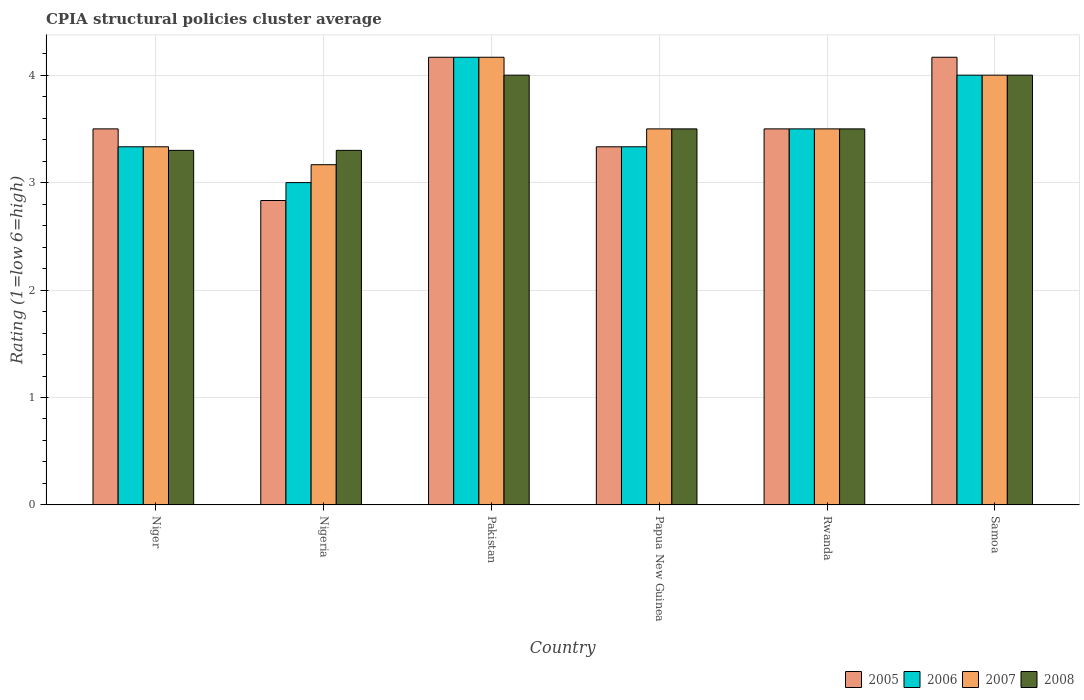How many groups of bars are there?
Offer a terse response. 6. Are the number of bars per tick equal to the number of legend labels?
Ensure brevity in your answer.  Yes. How many bars are there on the 2nd tick from the left?
Your response must be concise. 4. How many bars are there on the 6th tick from the right?
Make the answer very short. 4. What is the label of the 4th group of bars from the left?
Your response must be concise. Papua New Guinea. What is the CPIA rating in 2005 in Niger?
Provide a short and direct response. 3.5. Across all countries, what is the maximum CPIA rating in 2008?
Give a very brief answer. 4. Across all countries, what is the minimum CPIA rating in 2005?
Provide a short and direct response. 2.83. In which country was the CPIA rating in 2007 minimum?
Provide a succinct answer. Nigeria. What is the total CPIA rating in 2008 in the graph?
Offer a terse response. 21.6. What is the difference between the CPIA rating in 2005 in Papua New Guinea and the CPIA rating in 2007 in Nigeria?
Ensure brevity in your answer.  0.17. What is the average CPIA rating in 2008 per country?
Your answer should be compact. 3.6. What is the difference between the CPIA rating of/in 2008 and CPIA rating of/in 2006 in Papua New Guinea?
Your response must be concise. 0.17. What is the ratio of the CPIA rating in 2007 in Nigeria to that in Papua New Guinea?
Provide a succinct answer. 0.9. Is the CPIA rating in 2006 in Nigeria less than that in Pakistan?
Keep it short and to the point. Yes. What is the difference between the highest and the second highest CPIA rating in 2008?
Offer a very short reply. -0.5. What is the difference between the highest and the lowest CPIA rating in 2007?
Make the answer very short. 1. In how many countries, is the CPIA rating in 2006 greater than the average CPIA rating in 2006 taken over all countries?
Your response must be concise. 2. What does the 1st bar from the left in Samoa represents?
Your answer should be compact. 2005. Are all the bars in the graph horizontal?
Your answer should be compact. No. What is the difference between two consecutive major ticks on the Y-axis?
Your response must be concise. 1. Does the graph contain any zero values?
Make the answer very short. No. How many legend labels are there?
Make the answer very short. 4. How are the legend labels stacked?
Offer a very short reply. Horizontal. What is the title of the graph?
Give a very brief answer. CPIA structural policies cluster average. Does "1978" appear as one of the legend labels in the graph?
Your response must be concise. No. What is the label or title of the Y-axis?
Your answer should be very brief. Rating (1=low 6=high). What is the Rating (1=low 6=high) in 2005 in Niger?
Keep it short and to the point. 3.5. What is the Rating (1=low 6=high) in 2006 in Niger?
Keep it short and to the point. 3.33. What is the Rating (1=low 6=high) of 2007 in Niger?
Keep it short and to the point. 3.33. What is the Rating (1=low 6=high) in 2005 in Nigeria?
Your answer should be compact. 2.83. What is the Rating (1=low 6=high) of 2007 in Nigeria?
Make the answer very short. 3.17. What is the Rating (1=low 6=high) in 2005 in Pakistan?
Keep it short and to the point. 4.17. What is the Rating (1=low 6=high) in 2006 in Pakistan?
Keep it short and to the point. 4.17. What is the Rating (1=low 6=high) in 2007 in Pakistan?
Your answer should be very brief. 4.17. What is the Rating (1=low 6=high) of 2008 in Pakistan?
Ensure brevity in your answer.  4. What is the Rating (1=low 6=high) in 2005 in Papua New Guinea?
Ensure brevity in your answer.  3.33. What is the Rating (1=low 6=high) of 2006 in Papua New Guinea?
Offer a very short reply. 3.33. What is the Rating (1=low 6=high) of 2008 in Papua New Guinea?
Give a very brief answer. 3.5. What is the Rating (1=low 6=high) in 2005 in Rwanda?
Provide a short and direct response. 3.5. What is the Rating (1=low 6=high) in 2006 in Rwanda?
Provide a short and direct response. 3.5. What is the Rating (1=low 6=high) of 2008 in Rwanda?
Provide a short and direct response. 3.5. What is the Rating (1=low 6=high) in 2005 in Samoa?
Provide a short and direct response. 4.17. Across all countries, what is the maximum Rating (1=low 6=high) of 2005?
Your response must be concise. 4.17. Across all countries, what is the maximum Rating (1=low 6=high) in 2006?
Make the answer very short. 4.17. Across all countries, what is the maximum Rating (1=low 6=high) of 2007?
Offer a very short reply. 4.17. Across all countries, what is the maximum Rating (1=low 6=high) in 2008?
Offer a very short reply. 4. Across all countries, what is the minimum Rating (1=low 6=high) of 2005?
Your answer should be very brief. 2.83. Across all countries, what is the minimum Rating (1=low 6=high) in 2007?
Offer a terse response. 3.17. Across all countries, what is the minimum Rating (1=low 6=high) in 2008?
Provide a short and direct response. 3.3. What is the total Rating (1=low 6=high) of 2006 in the graph?
Your response must be concise. 21.33. What is the total Rating (1=low 6=high) in 2007 in the graph?
Make the answer very short. 21.67. What is the total Rating (1=low 6=high) of 2008 in the graph?
Keep it short and to the point. 21.6. What is the difference between the Rating (1=low 6=high) in 2006 in Niger and that in Nigeria?
Ensure brevity in your answer.  0.33. What is the difference between the Rating (1=low 6=high) in 2007 in Niger and that in Nigeria?
Make the answer very short. 0.17. What is the difference between the Rating (1=low 6=high) in 2005 in Niger and that in Pakistan?
Make the answer very short. -0.67. What is the difference between the Rating (1=low 6=high) in 2006 in Niger and that in Pakistan?
Provide a short and direct response. -0.83. What is the difference between the Rating (1=low 6=high) in 2008 in Niger and that in Pakistan?
Give a very brief answer. -0.7. What is the difference between the Rating (1=low 6=high) in 2005 in Niger and that in Papua New Guinea?
Make the answer very short. 0.17. What is the difference between the Rating (1=low 6=high) in 2006 in Niger and that in Papua New Guinea?
Provide a short and direct response. 0. What is the difference between the Rating (1=low 6=high) in 2007 in Niger and that in Papua New Guinea?
Your answer should be very brief. -0.17. What is the difference between the Rating (1=low 6=high) in 2005 in Niger and that in Rwanda?
Keep it short and to the point. 0. What is the difference between the Rating (1=low 6=high) in 2006 in Niger and that in Rwanda?
Provide a short and direct response. -0.17. What is the difference between the Rating (1=low 6=high) in 2008 in Niger and that in Rwanda?
Offer a terse response. -0.2. What is the difference between the Rating (1=low 6=high) of 2005 in Niger and that in Samoa?
Provide a short and direct response. -0.67. What is the difference between the Rating (1=low 6=high) of 2005 in Nigeria and that in Pakistan?
Provide a short and direct response. -1.33. What is the difference between the Rating (1=low 6=high) in 2006 in Nigeria and that in Pakistan?
Give a very brief answer. -1.17. What is the difference between the Rating (1=low 6=high) in 2008 in Nigeria and that in Pakistan?
Your answer should be compact. -0.7. What is the difference between the Rating (1=low 6=high) in 2005 in Nigeria and that in Papua New Guinea?
Offer a very short reply. -0.5. What is the difference between the Rating (1=low 6=high) of 2005 in Nigeria and that in Rwanda?
Provide a short and direct response. -0.67. What is the difference between the Rating (1=low 6=high) in 2006 in Nigeria and that in Rwanda?
Your response must be concise. -0.5. What is the difference between the Rating (1=low 6=high) of 2008 in Nigeria and that in Rwanda?
Keep it short and to the point. -0.2. What is the difference between the Rating (1=low 6=high) of 2005 in Nigeria and that in Samoa?
Make the answer very short. -1.33. What is the difference between the Rating (1=low 6=high) of 2006 in Nigeria and that in Samoa?
Your answer should be very brief. -1. What is the difference between the Rating (1=low 6=high) of 2008 in Nigeria and that in Samoa?
Your answer should be compact. -0.7. What is the difference between the Rating (1=low 6=high) in 2006 in Pakistan and that in Papua New Guinea?
Your response must be concise. 0.83. What is the difference between the Rating (1=low 6=high) in 2007 in Pakistan and that in Papua New Guinea?
Ensure brevity in your answer.  0.67. What is the difference between the Rating (1=low 6=high) of 2005 in Pakistan and that in Rwanda?
Offer a very short reply. 0.67. What is the difference between the Rating (1=low 6=high) of 2006 in Pakistan and that in Rwanda?
Your response must be concise. 0.67. What is the difference between the Rating (1=low 6=high) of 2007 in Pakistan and that in Rwanda?
Give a very brief answer. 0.67. What is the difference between the Rating (1=low 6=high) of 2008 in Pakistan and that in Rwanda?
Make the answer very short. 0.5. What is the difference between the Rating (1=low 6=high) of 2005 in Pakistan and that in Samoa?
Offer a terse response. 0. What is the difference between the Rating (1=low 6=high) of 2007 in Pakistan and that in Samoa?
Offer a very short reply. 0.17. What is the difference between the Rating (1=low 6=high) in 2005 in Papua New Guinea and that in Rwanda?
Offer a terse response. -0.17. What is the difference between the Rating (1=low 6=high) in 2008 in Papua New Guinea and that in Samoa?
Offer a very short reply. -0.5. What is the difference between the Rating (1=low 6=high) of 2006 in Rwanda and that in Samoa?
Keep it short and to the point. -0.5. What is the difference between the Rating (1=low 6=high) in 2007 in Rwanda and that in Samoa?
Your answer should be very brief. -0.5. What is the difference between the Rating (1=low 6=high) in 2005 in Niger and the Rating (1=low 6=high) in 2008 in Nigeria?
Your response must be concise. 0.2. What is the difference between the Rating (1=low 6=high) of 2006 in Niger and the Rating (1=low 6=high) of 2007 in Nigeria?
Offer a very short reply. 0.17. What is the difference between the Rating (1=low 6=high) in 2007 in Niger and the Rating (1=low 6=high) in 2008 in Nigeria?
Your response must be concise. 0.03. What is the difference between the Rating (1=low 6=high) in 2005 in Niger and the Rating (1=low 6=high) in 2008 in Papua New Guinea?
Keep it short and to the point. 0. What is the difference between the Rating (1=low 6=high) in 2006 in Niger and the Rating (1=low 6=high) in 2007 in Papua New Guinea?
Offer a very short reply. -0.17. What is the difference between the Rating (1=low 6=high) in 2007 in Niger and the Rating (1=low 6=high) in 2008 in Papua New Guinea?
Provide a short and direct response. -0.17. What is the difference between the Rating (1=low 6=high) of 2006 in Niger and the Rating (1=low 6=high) of 2008 in Rwanda?
Your answer should be very brief. -0.17. What is the difference between the Rating (1=low 6=high) in 2007 in Niger and the Rating (1=low 6=high) in 2008 in Rwanda?
Ensure brevity in your answer.  -0.17. What is the difference between the Rating (1=low 6=high) in 2005 in Niger and the Rating (1=low 6=high) in 2006 in Samoa?
Your response must be concise. -0.5. What is the difference between the Rating (1=low 6=high) in 2007 in Niger and the Rating (1=low 6=high) in 2008 in Samoa?
Your answer should be very brief. -0.67. What is the difference between the Rating (1=low 6=high) in 2005 in Nigeria and the Rating (1=low 6=high) in 2006 in Pakistan?
Make the answer very short. -1.33. What is the difference between the Rating (1=low 6=high) in 2005 in Nigeria and the Rating (1=low 6=high) in 2007 in Pakistan?
Give a very brief answer. -1.33. What is the difference between the Rating (1=low 6=high) of 2005 in Nigeria and the Rating (1=low 6=high) of 2008 in Pakistan?
Keep it short and to the point. -1.17. What is the difference between the Rating (1=low 6=high) in 2006 in Nigeria and the Rating (1=low 6=high) in 2007 in Pakistan?
Your answer should be very brief. -1.17. What is the difference between the Rating (1=low 6=high) in 2006 in Nigeria and the Rating (1=low 6=high) in 2008 in Pakistan?
Provide a succinct answer. -1. What is the difference between the Rating (1=low 6=high) in 2005 in Nigeria and the Rating (1=low 6=high) in 2008 in Papua New Guinea?
Your answer should be compact. -0.67. What is the difference between the Rating (1=low 6=high) of 2006 in Nigeria and the Rating (1=low 6=high) of 2008 in Papua New Guinea?
Give a very brief answer. -0.5. What is the difference between the Rating (1=low 6=high) in 2005 in Nigeria and the Rating (1=low 6=high) in 2008 in Rwanda?
Keep it short and to the point. -0.67. What is the difference between the Rating (1=low 6=high) in 2006 in Nigeria and the Rating (1=low 6=high) in 2008 in Rwanda?
Provide a succinct answer. -0.5. What is the difference between the Rating (1=low 6=high) of 2005 in Nigeria and the Rating (1=low 6=high) of 2006 in Samoa?
Ensure brevity in your answer.  -1.17. What is the difference between the Rating (1=low 6=high) in 2005 in Nigeria and the Rating (1=low 6=high) in 2007 in Samoa?
Make the answer very short. -1.17. What is the difference between the Rating (1=low 6=high) of 2005 in Nigeria and the Rating (1=low 6=high) of 2008 in Samoa?
Your answer should be very brief. -1.17. What is the difference between the Rating (1=low 6=high) of 2006 in Nigeria and the Rating (1=low 6=high) of 2008 in Samoa?
Your answer should be very brief. -1. What is the difference between the Rating (1=low 6=high) of 2007 in Nigeria and the Rating (1=low 6=high) of 2008 in Samoa?
Give a very brief answer. -0.83. What is the difference between the Rating (1=low 6=high) of 2005 in Pakistan and the Rating (1=low 6=high) of 2006 in Papua New Guinea?
Offer a very short reply. 0.83. What is the difference between the Rating (1=low 6=high) of 2005 in Pakistan and the Rating (1=low 6=high) of 2007 in Papua New Guinea?
Make the answer very short. 0.67. What is the difference between the Rating (1=low 6=high) of 2006 in Pakistan and the Rating (1=low 6=high) of 2007 in Papua New Guinea?
Provide a short and direct response. 0.67. What is the difference between the Rating (1=low 6=high) in 2006 in Pakistan and the Rating (1=low 6=high) in 2008 in Papua New Guinea?
Offer a terse response. 0.67. What is the difference between the Rating (1=low 6=high) in 2007 in Pakistan and the Rating (1=low 6=high) in 2008 in Papua New Guinea?
Offer a terse response. 0.67. What is the difference between the Rating (1=low 6=high) of 2005 in Pakistan and the Rating (1=low 6=high) of 2006 in Rwanda?
Your answer should be compact. 0.67. What is the difference between the Rating (1=low 6=high) of 2005 in Pakistan and the Rating (1=low 6=high) of 2008 in Rwanda?
Give a very brief answer. 0.67. What is the difference between the Rating (1=low 6=high) in 2006 in Pakistan and the Rating (1=low 6=high) in 2007 in Rwanda?
Provide a succinct answer. 0.67. What is the difference between the Rating (1=low 6=high) of 2006 in Pakistan and the Rating (1=low 6=high) of 2008 in Rwanda?
Ensure brevity in your answer.  0.67. What is the difference between the Rating (1=low 6=high) in 2005 in Pakistan and the Rating (1=low 6=high) in 2007 in Samoa?
Ensure brevity in your answer.  0.17. What is the difference between the Rating (1=low 6=high) of 2005 in Papua New Guinea and the Rating (1=low 6=high) of 2007 in Rwanda?
Provide a short and direct response. -0.17. What is the difference between the Rating (1=low 6=high) of 2005 in Papua New Guinea and the Rating (1=low 6=high) of 2008 in Rwanda?
Your response must be concise. -0.17. What is the difference between the Rating (1=low 6=high) in 2005 in Papua New Guinea and the Rating (1=low 6=high) in 2007 in Samoa?
Give a very brief answer. -0.67. What is the difference between the Rating (1=low 6=high) in 2005 in Papua New Guinea and the Rating (1=low 6=high) in 2008 in Samoa?
Make the answer very short. -0.67. What is the difference between the Rating (1=low 6=high) in 2006 in Papua New Guinea and the Rating (1=low 6=high) in 2007 in Samoa?
Provide a succinct answer. -0.67. What is the difference between the Rating (1=low 6=high) of 2007 in Papua New Guinea and the Rating (1=low 6=high) of 2008 in Samoa?
Ensure brevity in your answer.  -0.5. What is the difference between the Rating (1=low 6=high) of 2005 in Rwanda and the Rating (1=low 6=high) of 2007 in Samoa?
Offer a very short reply. -0.5. What is the difference between the Rating (1=low 6=high) in 2005 in Rwanda and the Rating (1=low 6=high) in 2008 in Samoa?
Provide a succinct answer. -0.5. What is the difference between the Rating (1=low 6=high) in 2007 in Rwanda and the Rating (1=low 6=high) in 2008 in Samoa?
Your response must be concise. -0.5. What is the average Rating (1=low 6=high) of 2005 per country?
Offer a very short reply. 3.58. What is the average Rating (1=low 6=high) of 2006 per country?
Offer a very short reply. 3.56. What is the average Rating (1=low 6=high) of 2007 per country?
Offer a terse response. 3.61. What is the difference between the Rating (1=low 6=high) in 2005 and Rating (1=low 6=high) in 2006 in Niger?
Your response must be concise. 0.17. What is the difference between the Rating (1=low 6=high) in 2005 and Rating (1=low 6=high) in 2007 in Niger?
Your answer should be compact. 0.17. What is the difference between the Rating (1=low 6=high) in 2007 and Rating (1=low 6=high) in 2008 in Niger?
Provide a short and direct response. 0.03. What is the difference between the Rating (1=low 6=high) in 2005 and Rating (1=low 6=high) in 2006 in Nigeria?
Provide a succinct answer. -0.17. What is the difference between the Rating (1=low 6=high) in 2005 and Rating (1=low 6=high) in 2007 in Nigeria?
Make the answer very short. -0.33. What is the difference between the Rating (1=low 6=high) in 2005 and Rating (1=low 6=high) in 2008 in Nigeria?
Your answer should be very brief. -0.47. What is the difference between the Rating (1=low 6=high) in 2006 and Rating (1=low 6=high) in 2008 in Nigeria?
Provide a short and direct response. -0.3. What is the difference between the Rating (1=low 6=high) in 2007 and Rating (1=low 6=high) in 2008 in Nigeria?
Your response must be concise. -0.13. What is the difference between the Rating (1=low 6=high) of 2005 and Rating (1=low 6=high) of 2008 in Pakistan?
Give a very brief answer. 0.17. What is the difference between the Rating (1=low 6=high) of 2006 and Rating (1=low 6=high) of 2007 in Pakistan?
Provide a short and direct response. 0. What is the difference between the Rating (1=low 6=high) in 2007 and Rating (1=low 6=high) in 2008 in Pakistan?
Provide a short and direct response. 0.17. What is the difference between the Rating (1=low 6=high) in 2005 and Rating (1=low 6=high) in 2006 in Papua New Guinea?
Your answer should be compact. 0. What is the difference between the Rating (1=low 6=high) in 2005 and Rating (1=low 6=high) in 2008 in Papua New Guinea?
Offer a very short reply. -0.17. What is the difference between the Rating (1=low 6=high) in 2006 and Rating (1=low 6=high) in 2007 in Papua New Guinea?
Ensure brevity in your answer.  -0.17. What is the difference between the Rating (1=low 6=high) in 2007 and Rating (1=low 6=high) in 2008 in Papua New Guinea?
Your answer should be compact. 0. What is the difference between the Rating (1=low 6=high) in 2005 and Rating (1=low 6=high) in 2008 in Rwanda?
Your response must be concise. 0. What is the difference between the Rating (1=low 6=high) of 2005 and Rating (1=low 6=high) of 2006 in Samoa?
Your answer should be very brief. 0.17. What is the difference between the Rating (1=low 6=high) in 2006 and Rating (1=low 6=high) in 2008 in Samoa?
Ensure brevity in your answer.  0. What is the ratio of the Rating (1=low 6=high) in 2005 in Niger to that in Nigeria?
Ensure brevity in your answer.  1.24. What is the ratio of the Rating (1=low 6=high) in 2007 in Niger to that in Nigeria?
Ensure brevity in your answer.  1.05. What is the ratio of the Rating (1=low 6=high) in 2008 in Niger to that in Nigeria?
Ensure brevity in your answer.  1. What is the ratio of the Rating (1=low 6=high) of 2005 in Niger to that in Pakistan?
Offer a very short reply. 0.84. What is the ratio of the Rating (1=low 6=high) of 2007 in Niger to that in Pakistan?
Keep it short and to the point. 0.8. What is the ratio of the Rating (1=low 6=high) in 2008 in Niger to that in Pakistan?
Ensure brevity in your answer.  0.82. What is the ratio of the Rating (1=low 6=high) in 2006 in Niger to that in Papua New Guinea?
Provide a succinct answer. 1. What is the ratio of the Rating (1=low 6=high) of 2007 in Niger to that in Papua New Guinea?
Offer a terse response. 0.95. What is the ratio of the Rating (1=low 6=high) in 2008 in Niger to that in Papua New Guinea?
Keep it short and to the point. 0.94. What is the ratio of the Rating (1=low 6=high) of 2005 in Niger to that in Rwanda?
Offer a very short reply. 1. What is the ratio of the Rating (1=low 6=high) of 2006 in Niger to that in Rwanda?
Offer a very short reply. 0.95. What is the ratio of the Rating (1=low 6=high) in 2007 in Niger to that in Rwanda?
Your response must be concise. 0.95. What is the ratio of the Rating (1=low 6=high) of 2008 in Niger to that in Rwanda?
Your response must be concise. 0.94. What is the ratio of the Rating (1=low 6=high) of 2005 in Niger to that in Samoa?
Give a very brief answer. 0.84. What is the ratio of the Rating (1=low 6=high) of 2007 in Niger to that in Samoa?
Provide a succinct answer. 0.83. What is the ratio of the Rating (1=low 6=high) of 2008 in Niger to that in Samoa?
Give a very brief answer. 0.82. What is the ratio of the Rating (1=low 6=high) in 2005 in Nigeria to that in Pakistan?
Offer a very short reply. 0.68. What is the ratio of the Rating (1=low 6=high) in 2006 in Nigeria to that in Pakistan?
Make the answer very short. 0.72. What is the ratio of the Rating (1=low 6=high) in 2007 in Nigeria to that in Pakistan?
Offer a very short reply. 0.76. What is the ratio of the Rating (1=low 6=high) of 2008 in Nigeria to that in Pakistan?
Offer a terse response. 0.82. What is the ratio of the Rating (1=low 6=high) of 2005 in Nigeria to that in Papua New Guinea?
Your response must be concise. 0.85. What is the ratio of the Rating (1=low 6=high) in 2007 in Nigeria to that in Papua New Guinea?
Provide a short and direct response. 0.9. What is the ratio of the Rating (1=low 6=high) of 2008 in Nigeria to that in Papua New Guinea?
Offer a very short reply. 0.94. What is the ratio of the Rating (1=low 6=high) of 2005 in Nigeria to that in Rwanda?
Provide a short and direct response. 0.81. What is the ratio of the Rating (1=low 6=high) of 2007 in Nigeria to that in Rwanda?
Your answer should be compact. 0.9. What is the ratio of the Rating (1=low 6=high) of 2008 in Nigeria to that in Rwanda?
Provide a succinct answer. 0.94. What is the ratio of the Rating (1=low 6=high) of 2005 in Nigeria to that in Samoa?
Make the answer very short. 0.68. What is the ratio of the Rating (1=low 6=high) in 2006 in Nigeria to that in Samoa?
Give a very brief answer. 0.75. What is the ratio of the Rating (1=low 6=high) of 2007 in Nigeria to that in Samoa?
Keep it short and to the point. 0.79. What is the ratio of the Rating (1=low 6=high) of 2008 in Nigeria to that in Samoa?
Offer a terse response. 0.82. What is the ratio of the Rating (1=low 6=high) in 2005 in Pakistan to that in Papua New Guinea?
Keep it short and to the point. 1.25. What is the ratio of the Rating (1=low 6=high) in 2006 in Pakistan to that in Papua New Guinea?
Make the answer very short. 1.25. What is the ratio of the Rating (1=low 6=high) of 2007 in Pakistan to that in Papua New Guinea?
Ensure brevity in your answer.  1.19. What is the ratio of the Rating (1=low 6=high) of 2008 in Pakistan to that in Papua New Guinea?
Provide a short and direct response. 1.14. What is the ratio of the Rating (1=low 6=high) in 2005 in Pakistan to that in Rwanda?
Provide a short and direct response. 1.19. What is the ratio of the Rating (1=low 6=high) of 2006 in Pakistan to that in Rwanda?
Your answer should be very brief. 1.19. What is the ratio of the Rating (1=low 6=high) in 2007 in Pakistan to that in Rwanda?
Keep it short and to the point. 1.19. What is the ratio of the Rating (1=low 6=high) in 2008 in Pakistan to that in Rwanda?
Provide a short and direct response. 1.14. What is the ratio of the Rating (1=low 6=high) in 2006 in Pakistan to that in Samoa?
Offer a terse response. 1.04. What is the ratio of the Rating (1=low 6=high) in 2007 in Pakistan to that in Samoa?
Provide a succinct answer. 1.04. What is the ratio of the Rating (1=low 6=high) in 2005 in Papua New Guinea to that in Rwanda?
Give a very brief answer. 0.95. What is the ratio of the Rating (1=low 6=high) of 2006 in Papua New Guinea to that in Rwanda?
Your response must be concise. 0.95. What is the ratio of the Rating (1=low 6=high) of 2007 in Papua New Guinea to that in Rwanda?
Your answer should be very brief. 1. What is the ratio of the Rating (1=low 6=high) of 2006 in Papua New Guinea to that in Samoa?
Keep it short and to the point. 0.83. What is the ratio of the Rating (1=low 6=high) in 2007 in Papua New Guinea to that in Samoa?
Your answer should be very brief. 0.88. What is the ratio of the Rating (1=low 6=high) of 2005 in Rwanda to that in Samoa?
Ensure brevity in your answer.  0.84. What is the ratio of the Rating (1=low 6=high) in 2006 in Rwanda to that in Samoa?
Keep it short and to the point. 0.88. What is the ratio of the Rating (1=low 6=high) of 2007 in Rwanda to that in Samoa?
Your answer should be compact. 0.88. What is the ratio of the Rating (1=low 6=high) of 2008 in Rwanda to that in Samoa?
Offer a very short reply. 0.88. What is the difference between the highest and the second highest Rating (1=low 6=high) in 2007?
Your answer should be very brief. 0.17. What is the difference between the highest and the second highest Rating (1=low 6=high) in 2008?
Provide a short and direct response. 0. 